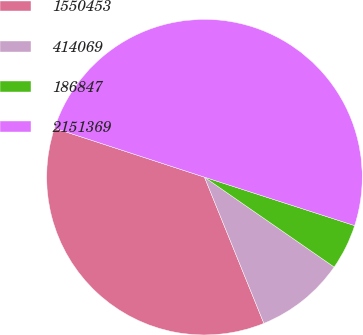<chart> <loc_0><loc_0><loc_500><loc_500><pie_chart><fcel>1550453<fcel>414069<fcel>186847<fcel>2151369<nl><fcel>36.17%<fcel>9.21%<fcel>4.68%<fcel>49.94%<nl></chart> 